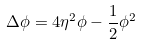Convert formula to latex. <formula><loc_0><loc_0><loc_500><loc_500>\Delta \phi = 4 \eta ^ { 2 } \phi - \frac { 1 } { 2 } \phi ^ { 2 }</formula> 